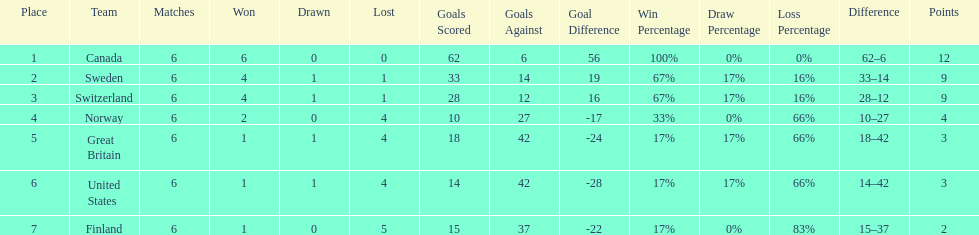What team placed next after sweden? Switzerland. 